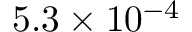Convert formula to latex. <formula><loc_0><loc_0><loc_500><loc_500>5 . 3 \times 1 0 ^ { - 4 }</formula> 